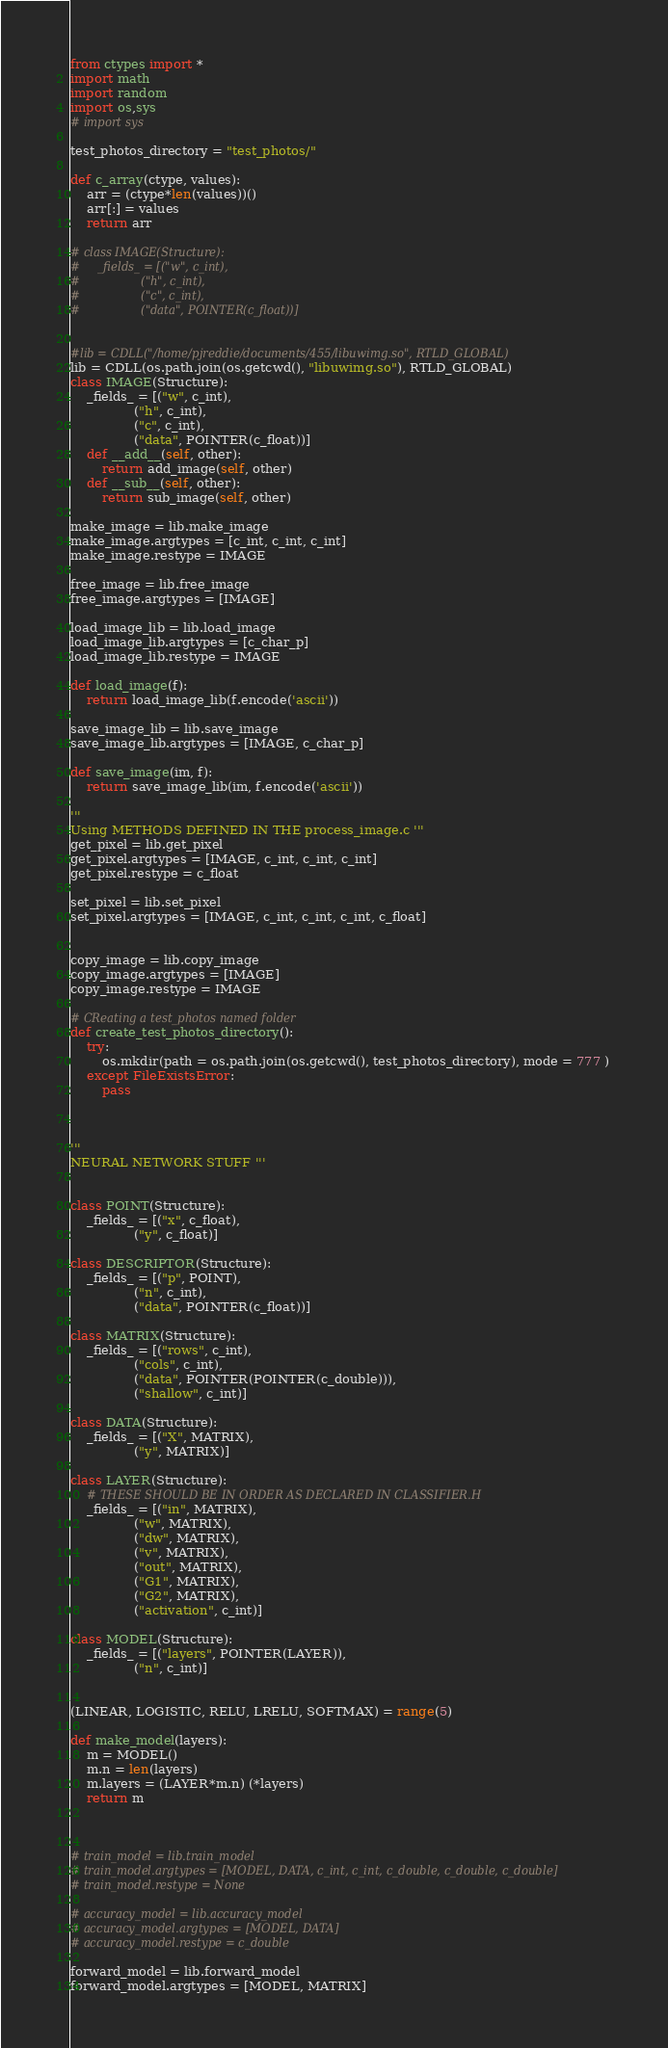Convert code to text. <code><loc_0><loc_0><loc_500><loc_500><_Python_>from ctypes import *
import math
import random
import os,sys
# import sys

test_photos_directory = "test_photos/"

def c_array(ctype, values):
    arr = (ctype*len(values))()
    arr[:] = values
    return arr

# class IMAGE(Structure):
#     _fields_ = [("w", c_int),
#                 ("h", c_int),
#                 ("c", c_int),
#                 ("data", POINTER(c_float))]


#lib = CDLL("/home/pjreddie/documents/455/libuwimg.so", RTLD_GLOBAL)
lib = CDLL(os.path.join(os.getcwd(), "libuwimg.so"), RTLD_GLOBAL) 
class IMAGE(Structure):
    _fields_ = [("w", c_int),
                ("h", c_int),
                ("c", c_int),
                ("data", POINTER(c_float))]
    def __add__(self, other):
        return add_image(self, other)
    def __sub__(self, other):
        return sub_image(self, other)

make_image = lib.make_image
make_image.argtypes = [c_int, c_int, c_int]
make_image.restype = IMAGE

free_image = lib.free_image
free_image.argtypes = [IMAGE]

load_image_lib = lib.load_image
load_image_lib.argtypes = [c_char_p]
load_image_lib.restype = IMAGE

def load_image(f):
    return load_image_lib(f.encode('ascii'))

save_image_lib = lib.save_image
save_image_lib.argtypes = [IMAGE, c_char_p]

def save_image(im, f):
    return save_image_lib(im, f.encode('ascii'))

'''
Using METHODS DEFINED IN THE process_image.c '''
get_pixel = lib.get_pixel
get_pixel.argtypes = [IMAGE, c_int, c_int, c_int]
get_pixel.restype = c_float

set_pixel = lib.set_pixel
set_pixel.argtypes = [IMAGE, c_int, c_int, c_int, c_float]


copy_image = lib.copy_image
copy_image.argtypes = [IMAGE]
copy_image.restype = IMAGE

# CReating a test_photos named folder
def create_test_photos_directory():    
    try:
        os.mkdir(path = os.path.join(os.getcwd(), test_photos_directory), mode = 777 )
    except FileExistsError:
        pass 



'''
NEURAL NETWORK STUFF '''


class POINT(Structure):
    _fields_ = [("x", c_float),
                ("y", c_float)]

class DESCRIPTOR(Structure):
    _fields_ = [("p", POINT),
                ("n", c_int),
                ("data", POINTER(c_float))]

class MATRIX(Structure):
    _fields_ = [("rows", c_int),
                ("cols", c_int),
                ("data", POINTER(POINTER(c_double))),
                ("shallow", c_int)]

class DATA(Structure):
    _fields_ = [("X", MATRIX),
                ("y", MATRIX)]

class LAYER(Structure):
    # THESE SHOULD BE IN ORDER AS DECLARED IN CLASSIFIER.H
    _fields_ = [("in", MATRIX),
                ("w", MATRIX),
                ("dw", MATRIX),
                ("v", MATRIX),
                ("out", MATRIX),
                ("G1", MATRIX),
                ("G2", MATRIX),
                ("activation", c_int)]

class MODEL(Structure):
    _fields_ = [("layers", POINTER(LAYER)),
                ("n", c_int)]


(LINEAR, LOGISTIC, RELU, LRELU, SOFTMAX) = range(5)

def make_model(layers):
    m = MODEL()
    m.n = len(layers)
    m.layers = (LAYER*m.n) (*layers)
    return m



# train_model = lib.train_model
# train_model.argtypes = [MODEL, DATA, c_int, c_int, c_double, c_double, c_double]
# train_model.restype = None

# accuracy_model = lib.accuracy_model
# accuracy_model.argtypes = [MODEL, DATA]
# accuracy_model.restype = c_double

forward_model = lib.forward_model
forward_model.argtypes = [MODEL, MATRIX]</code> 